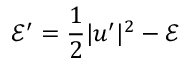<formula> <loc_0><loc_0><loc_500><loc_500>\mathcal { E } ^ { \prime } = \frac { 1 } { 2 } | \boldsymbol u ^ { \prime } | ^ { 2 } - \mathcal { E }</formula> 